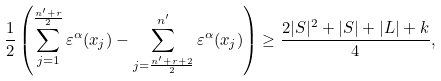<formula> <loc_0><loc_0><loc_500><loc_500>\frac { 1 } { 2 } \left ( \sum _ { j = 1 } ^ { \frac { n ^ { \prime } + r } { 2 } } \varepsilon ^ { \alpha } ( x _ { j } ) - \sum _ { j = \frac { n ^ { \prime } + r + 2 } { 2 } } ^ { n ^ { \prime } } \varepsilon ^ { \alpha } ( x _ { j } ) \right ) \geq \frac { 2 | S | ^ { 2 } + | S | + | L | + k } { 4 } ,</formula> 